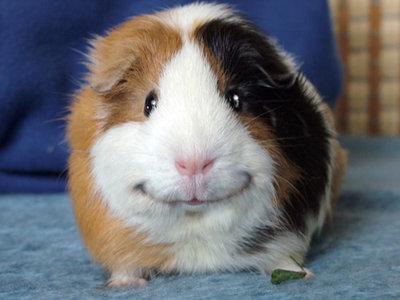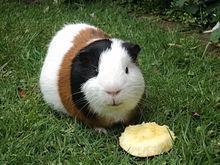The first image is the image on the left, the second image is the image on the right. Examine the images to the left and right. Is the description "There are three guinea pigs" accurate? Answer yes or no. No. 